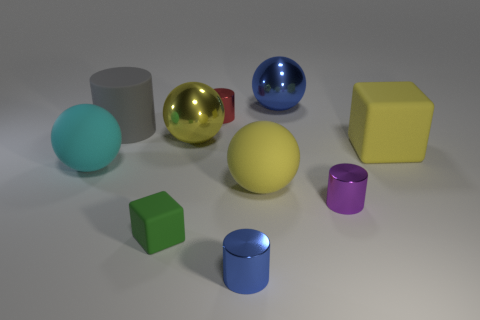Does the ball in front of the cyan matte ball have the same size as the yellow rubber thing that is to the right of the small purple metallic object?
Provide a short and direct response. Yes. What number of tiny cubes are there?
Your answer should be very brief. 1. How many large green things are made of the same material as the gray thing?
Your answer should be compact. 0. Are there the same number of small shiny things behind the tiny matte cube and things?
Provide a short and direct response. No. There is a yellow shiny thing; does it have the same size as the blue object that is behind the gray matte thing?
Provide a succinct answer. Yes. What number of other things are the same size as the purple shiny cylinder?
Your response must be concise. 3. What number of other things are there of the same color as the small matte block?
Provide a short and direct response. 0. What number of other objects are the same shape as the gray object?
Offer a terse response. 3. Is the matte cylinder the same size as the purple cylinder?
Your response must be concise. No. Is there a large yellow sphere?
Ensure brevity in your answer.  Yes. 